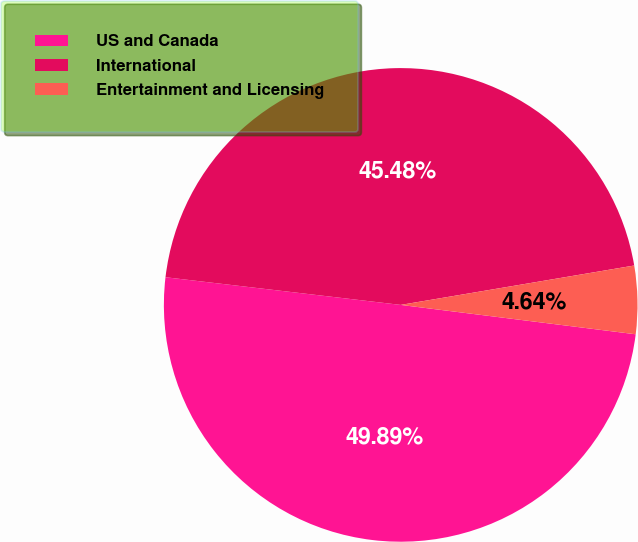Convert chart. <chart><loc_0><loc_0><loc_500><loc_500><pie_chart><fcel>US and Canada<fcel>International<fcel>Entertainment and Licensing<nl><fcel>49.89%<fcel>45.48%<fcel>4.64%<nl></chart> 